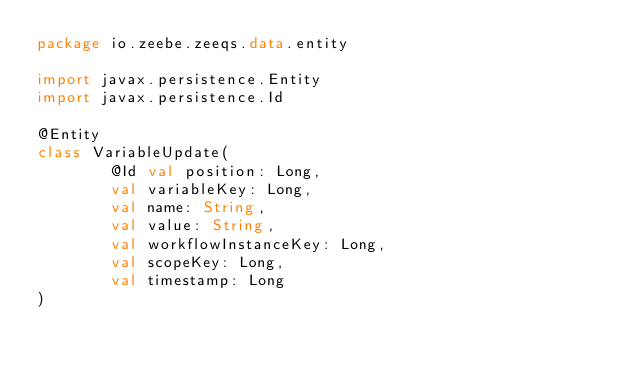Convert code to text. <code><loc_0><loc_0><loc_500><loc_500><_Kotlin_>package io.zeebe.zeeqs.data.entity

import javax.persistence.Entity
import javax.persistence.Id

@Entity
class VariableUpdate(
        @Id val position: Long,
        val variableKey: Long,
        val name: String,
        val value: String,
        val workflowInstanceKey: Long,
        val scopeKey: Long,
        val timestamp: Long
)</code> 